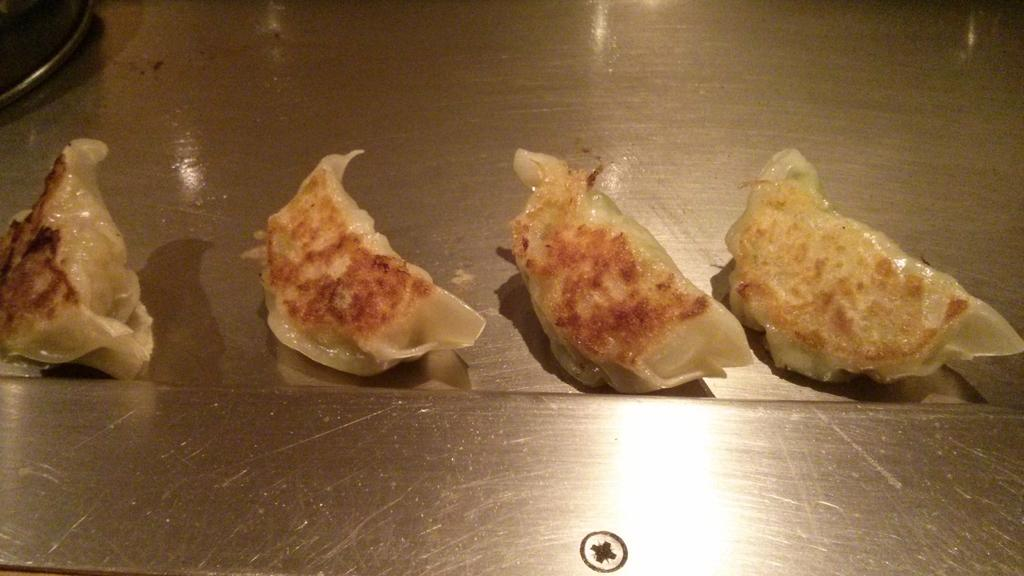What is the main subject of the image? The main subject of the image is food. Where is the food located in the image? The food is in the center of the image. What language is spoken by the grain in the image? There is no grain present in the image, and therefore no language can be attributed to it. 